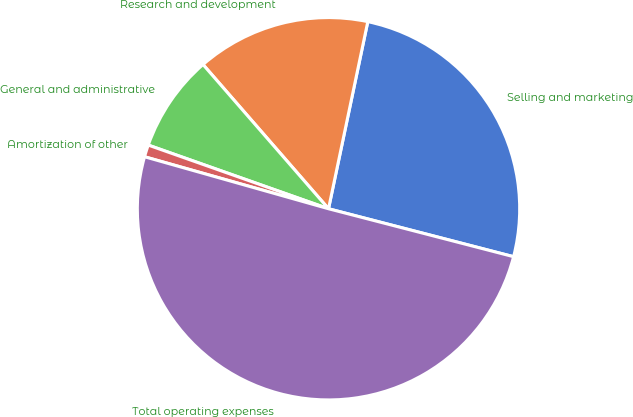<chart> <loc_0><loc_0><loc_500><loc_500><pie_chart><fcel>Selling and marketing<fcel>Research and development<fcel>General and administrative<fcel>Amortization of other<fcel>Total operating expenses<nl><fcel>25.74%<fcel>14.69%<fcel>8.2%<fcel>1.02%<fcel>50.35%<nl></chart> 